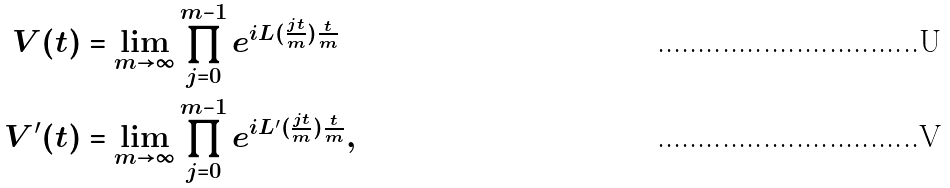Convert formula to latex. <formula><loc_0><loc_0><loc_500><loc_500>V ( t ) & = \lim _ { m \rightarrow \infty } \prod _ { j = 0 } ^ { m - 1 } e ^ { i L ( \frac { j t } { m } ) \frac { t } { m } } \\ V ^ { \prime } ( t ) & = \lim _ { m \rightarrow \infty } \prod _ { j = 0 } ^ { m - 1 } e ^ { i L ^ { \prime } ( \frac { j t } { m } ) \frac { t } { m } } ,</formula> 